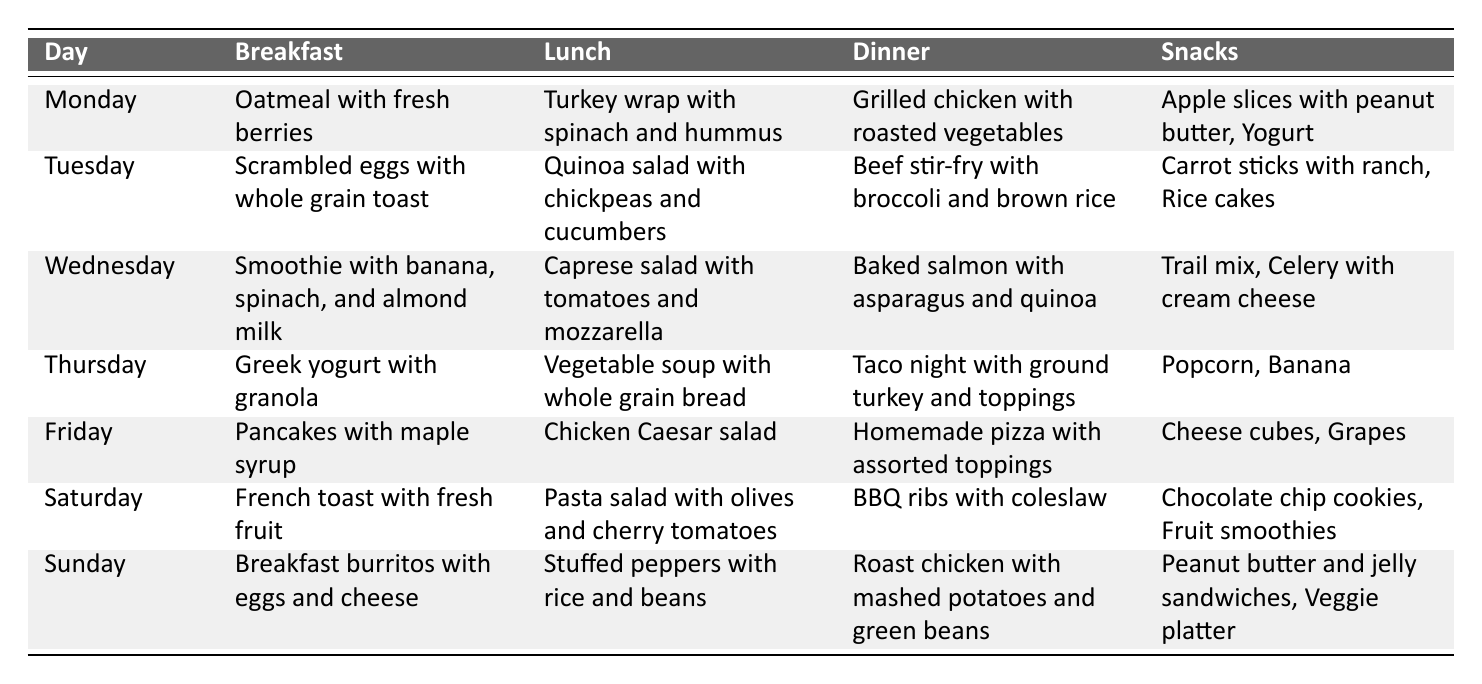What is served for breakfast on Wednesday? The table indicates that on Wednesday, the breakfast is a smoothie with banana, spinach, and almond milk.
Answer: Smoothie with banana, spinach, and almond milk How many meals are planned for Saturday? For Saturday, the table lists three meals: breakfast (French toast), lunch (pasta salad), and dinner (BBQ ribs), totaling three meals.
Answer: Three meals Is there a vegetarian option for lunch on Tuesday? The lunch option for Tuesday is a quinoa salad with chickpeas and cucumbers, which is suitable for vegetarians.
Answer: Yes Which day has tacos for dinner? The table shows that taco night is on Thursday, confirming that tacos are served for dinner on that day.
Answer: Thursday What are the snacks listed for Friday? The snacks for Friday are cheese cubes and grapes, as indicated in the table.
Answer: Cheese cubes, grapes How many days have breakfast options that include fruit? Breakfast options that include fruit are found on Monday (oatmeal with fresh berries), Wednesday (smoothie), Saturday (French toast with fresh fruit), and Sunday (breakfast burritos with eggs and cheese). That accounts for four days.
Answer: Four days Which meals include beans? The meals that include beans are the lunch on Sunday (stuffed peppers with rice and beans) and no other meals from the table contain beans.
Answer: Lunch on Sunday Which day has the highest number of snacks listed? Saturday has the most snacks listed, with chocolate chip cookies and fruit smoothies, totaling two snacks, whereas other days have at least one or two snacks.
Answer: Saturday What main ingredient is used in the dinner for Tuesday? The dinner for Tuesday features beef as the main ingredient in the beef stir-fry.
Answer: Beef Are any meals served multiple times throughout the week? The table shows that meals like chicken and various soups aren’t repeatedly listed as they are distinct for each day, so none are repeated.
Answer: No 